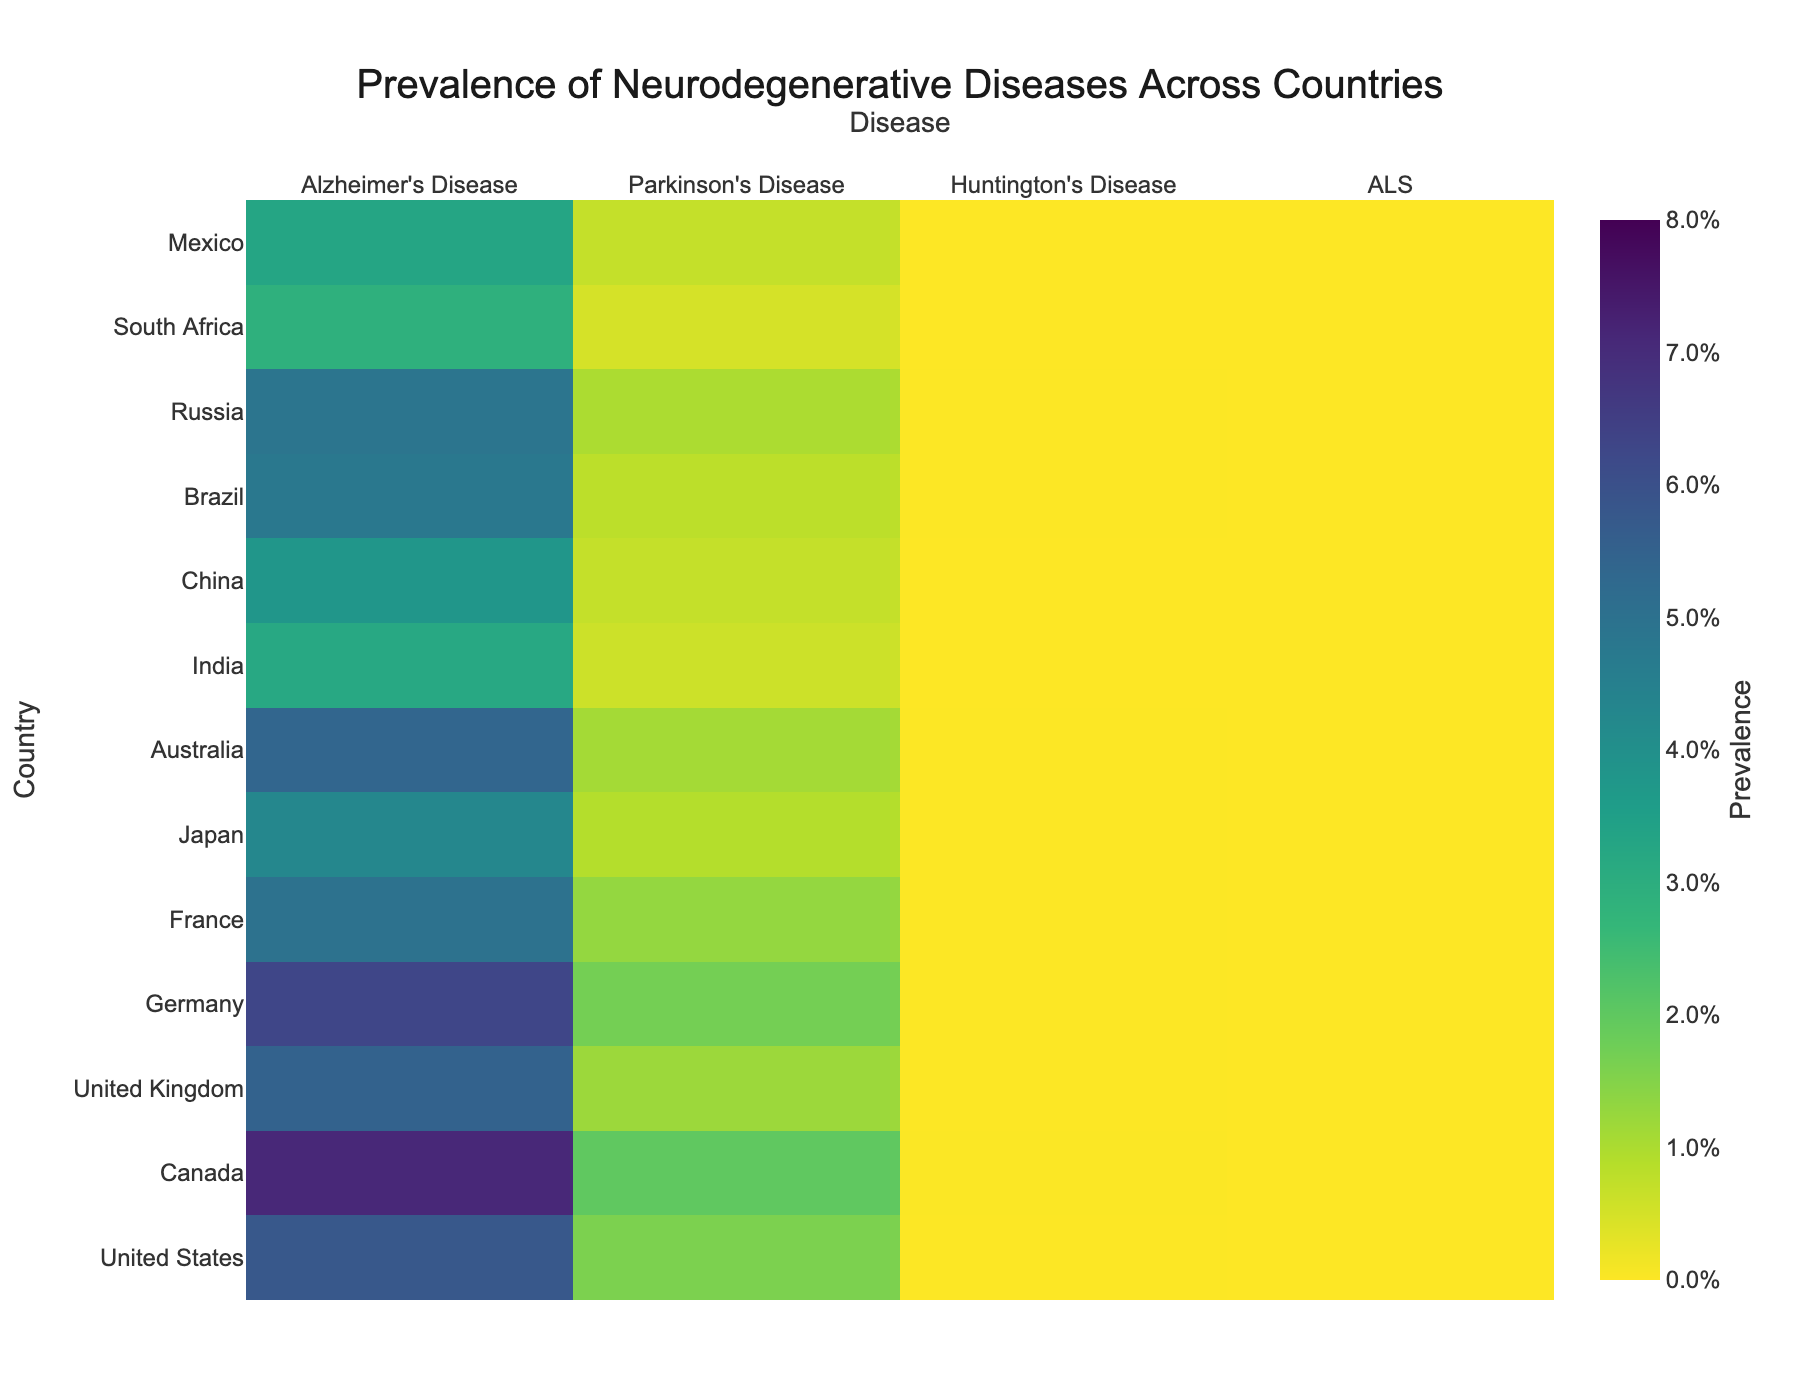What is the title of the heatmap? The title of the heatmap is typically located at the top of the figure. It is "Prevalence of Neurodegenerative Diseases Across Countries" in this case.
Answer: Prevalence of Neurodegenerative Diseases Across Countries Which country has the highest prevalence of Alzheimer's Disease? To determine this, find the column labeled "Alzheimer's Disease" and look for the highest value within that column. The highest value is 7.1%, which corresponds to Canada.
Answer: Canada What is the prevalence of ALS in Japan compared to Brazil? First, identify the values for ALS in Japan and Brazil in the "ALS" column. Japan has 0.003% and Brazil has 0.003%. Thus, both have the same prevalence.
Answer: 0.003% How does the prevalence of Parkinson's Disease in the United States compare to that in Germany? Look at the "Parkinson's Disease" column and note the values for both the United States and Germany. The U.S. has 1.6%, and Germany has 1.7%. Germany has a slightly higher prevalence.
Answer: Germany has a slightly higher prevalence What's the sum of the prevalence rates of Huntington's Disease in the United Kingdom and Australia? Add the prevalence rates of Huntington's Disease in the United Kingdom and Australia. The values are 0.01% and 0.01%, respectively. The sum is 0.02%.
Answer: 0.02% Which country has the lowest prevalence of neurodegenerative diseases overall, based on the color intensity in the heatmap? Countries with lower prevalence rates will have lighter color intensities. South Africa has the lowest values across all diseases, indicating it has the lowest overall prevalence of neurodegenerative diseases.
Answer: South Africa How does the prevalence of Alzheimer’s Disease in China compare to that in India? Look at the values for Alzheimer's Disease in China and India. China has a prevalence of 3.8%, while India has 3.2%. Therefore, China's prevalence is slightly higher.
Answer: China has a slightly higher prevalence What is the difference in prevalence of Huntington's Disease between the United States and Mexico? Subtract the prevalence of Huntington's Disease in Mexico from that in the United States. The values are 0.01% for the U.S. and 0.005% for Mexico. The difference is 0.005%.
Answer: 0.005% Among the listed countries, which displays the highest prevalence of Parkinson's Disease? To find this, scan the "Parkinson's Disease" column for the highest value. The highest value here is 2.0%, which corresponds to Canada.
Answer: Canada What is the average prevalence of ALS across all the countries? To compute this, sum all the prevalence rates for ALS and then divide by the number of countries (13). The values are: 0.005%, 0.006%, 0.004%, 0.005%, 0.004%, 0.003%, 0.0045%, 0.002%, 0.0025%, 0.003%, 0.0035%, 0.0015%, and 0.002%. Summing these gives 0.0465%. Dividing by 13 gives an average prevalence of approximately 0.0036%.
Answer: 0.0036% 